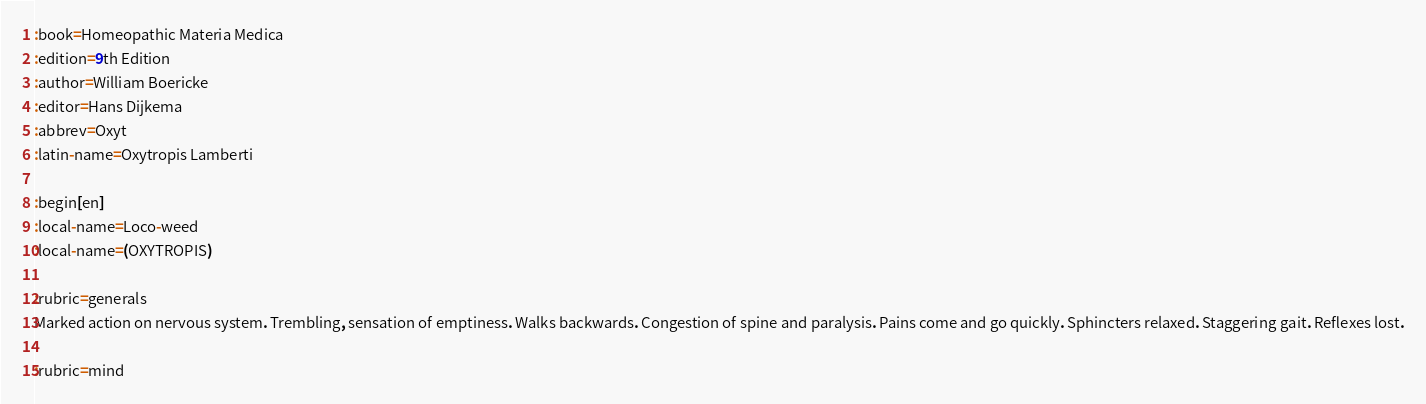Convert code to text. <code><loc_0><loc_0><loc_500><loc_500><_ObjectiveC_>:book=Homeopathic Materia Medica
:edition=9th Edition
:author=William Boericke
:editor=Hans Dijkema
:abbrev=Oxyt
:latin-name=Oxytropis Lamberti

:begin[en]
:local-name=Loco-weed
:local-name=(OXYTROPIS)

:rubric=generals
Marked action on nervous system. Trembling, sensation of emptiness. Walks backwards. Congestion of spine and paralysis. Pains come and go quickly. Sphincters relaxed. Staggering gait. Reflexes lost.

:rubric=mind</code> 